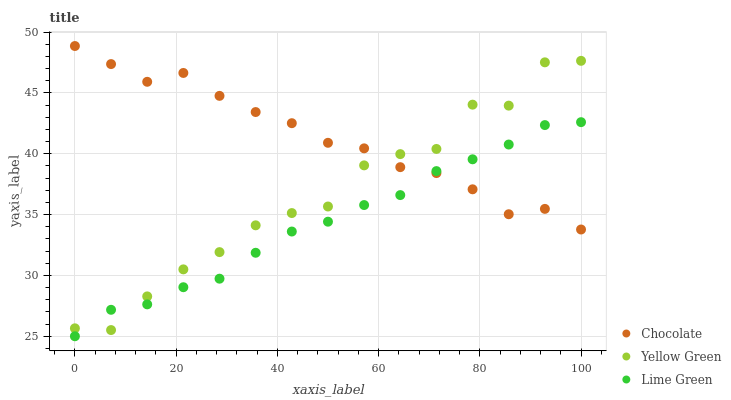Does Lime Green have the minimum area under the curve?
Answer yes or no. Yes. Does Chocolate have the maximum area under the curve?
Answer yes or no. Yes. Does Yellow Green have the minimum area under the curve?
Answer yes or no. No. Does Yellow Green have the maximum area under the curve?
Answer yes or no. No. Is Lime Green the smoothest?
Answer yes or no. Yes. Is Yellow Green the roughest?
Answer yes or no. Yes. Is Chocolate the smoothest?
Answer yes or no. No. Is Chocolate the roughest?
Answer yes or no. No. Does Lime Green have the lowest value?
Answer yes or no. Yes. Does Yellow Green have the lowest value?
Answer yes or no. No. Does Chocolate have the highest value?
Answer yes or no. Yes. Does Yellow Green have the highest value?
Answer yes or no. No. Does Lime Green intersect Chocolate?
Answer yes or no. Yes. Is Lime Green less than Chocolate?
Answer yes or no. No. Is Lime Green greater than Chocolate?
Answer yes or no. No. 